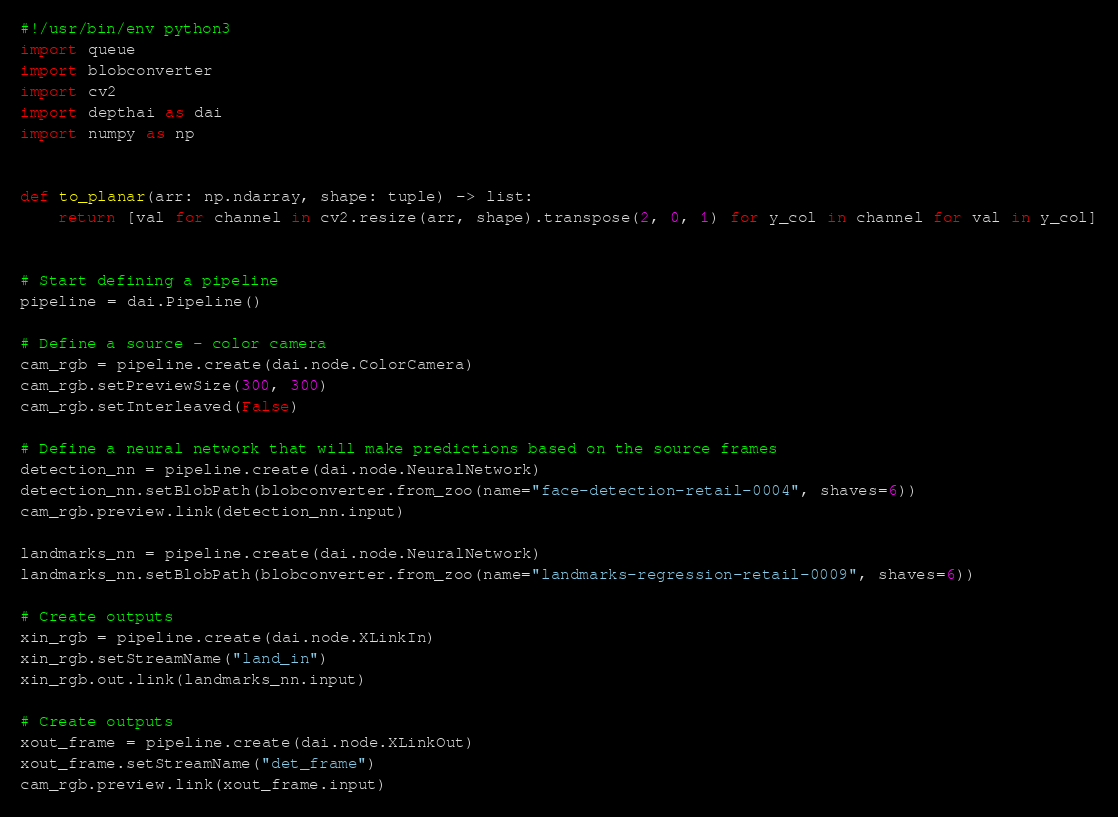<code> <loc_0><loc_0><loc_500><loc_500><_Python_>#!/usr/bin/env python3
import queue
import blobconverter
import cv2
import depthai as dai
import numpy as np


def to_planar(arr: np.ndarray, shape: tuple) -> list:
    return [val for channel in cv2.resize(arr, shape).transpose(2, 0, 1) for y_col in channel for val in y_col]


# Start defining a pipeline
pipeline = dai.Pipeline()

# Define a source - color camera
cam_rgb = pipeline.create(dai.node.ColorCamera)
cam_rgb.setPreviewSize(300, 300)
cam_rgb.setInterleaved(False)

# Define a neural network that will make predictions based on the source frames
detection_nn = pipeline.create(dai.node.NeuralNetwork)
detection_nn.setBlobPath(blobconverter.from_zoo(name="face-detection-retail-0004", shaves=6))
cam_rgb.preview.link(detection_nn.input)

landmarks_nn = pipeline.create(dai.node.NeuralNetwork)
landmarks_nn.setBlobPath(blobconverter.from_zoo(name="landmarks-regression-retail-0009", shaves=6))

# Create outputs
xin_rgb = pipeline.create(dai.node.XLinkIn)
xin_rgb.setStreamName("land_in")
xin_rgb.out.link(landmarks_nn.input)

# Create outputs
xout_frame = pipeline.create(dai.node.XLinkOut)
xout_frame.setStreamName("det_frame")
cam_rgb.preview.link(xout_frame.input)
</code> 